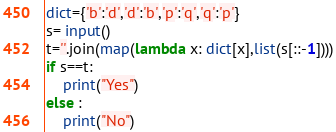Convert code to text. <code><loc_0><loc_0><loc_500><loc_500><_Python_>dict={'b':'d','d':'b','p':'q','q':'p'}
s= input()
t=''.join(map(lambda x: dict[x],list(s[::-1])))
if s==t:
    print("Yes")
else :
    print("No")</code> 